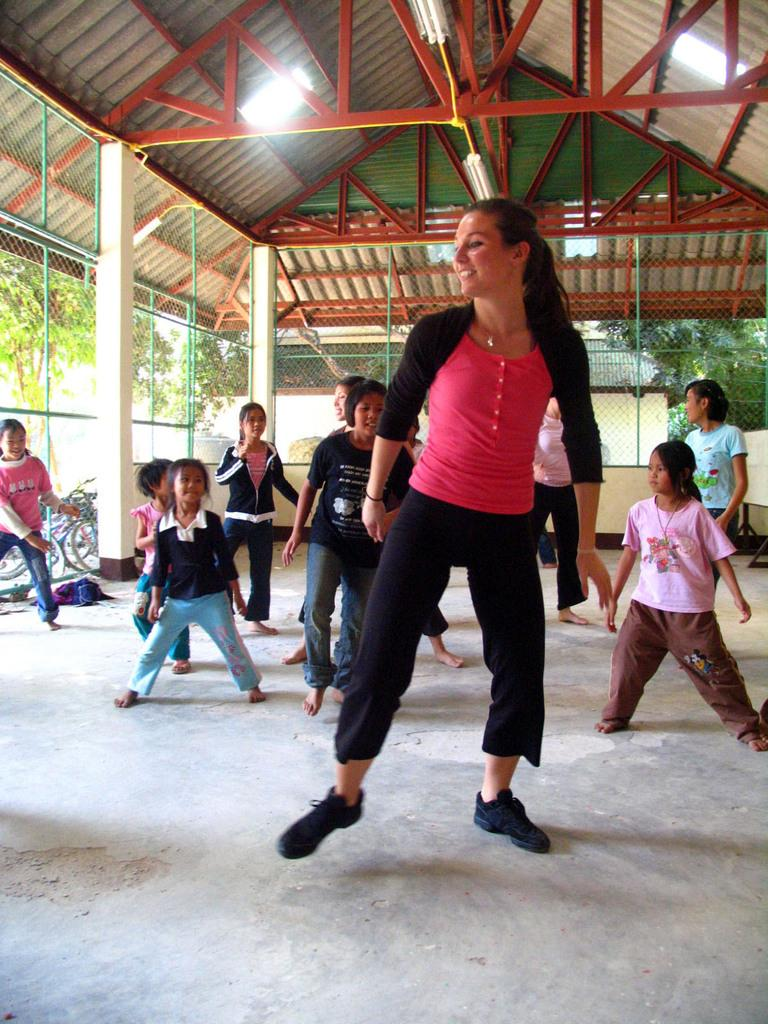Who is present in the image? There is a woman in the image. What is the location of the scene? The setting is an open shed. What can be seen in the background of the image? There are children, bicycles, trees, a mesh, and rods in the background of the image. How much payment is required to cross the quicksand in the image? There is no quicksand present in the image, so no payment is required. How many cows are visible in the image? There are no cows present in the image. 